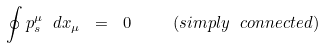Convert formula to latex. <formula><loc_0><loc_0><loc_500><loc_500>\oint { p ^ { \mu } _ { s } } \ d x _ { \mu } \ = \ 0 \quad \ ( s i m p l y \ c o n n e c t e d )</formula> 